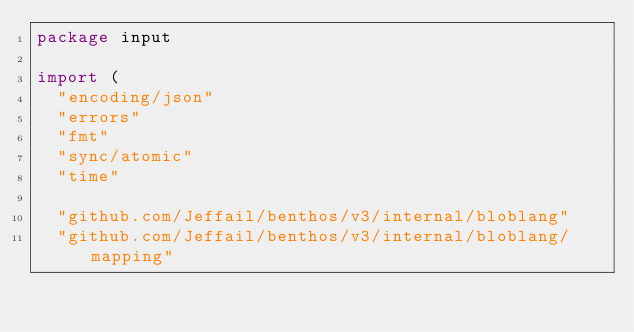<code> <loc_0><loc_0><loc_500><loc_500><_Go_>package input

import (
	"encoding/json"
	"errors"
	"fmt"
	"sync/atomic"
	"time"

	"github.com/Jeffail/benthos/v3/internal/bloblang"
	"github.com/Jeffail/benthos/v3/internal/bloblang/mapping"</code> 